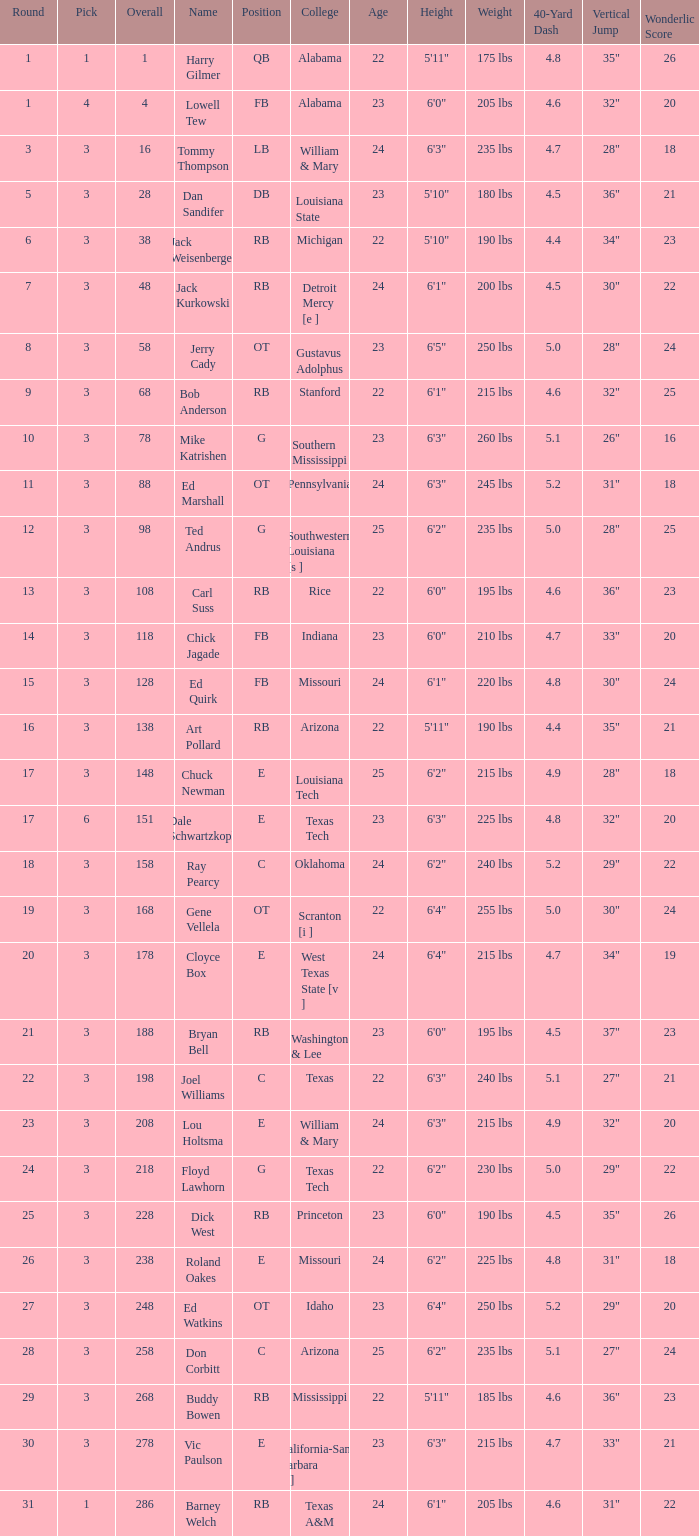Which pick has a Round smaller than 8, and an Overall smaller than 16, and a Name of harry gilmer? 1.0. 